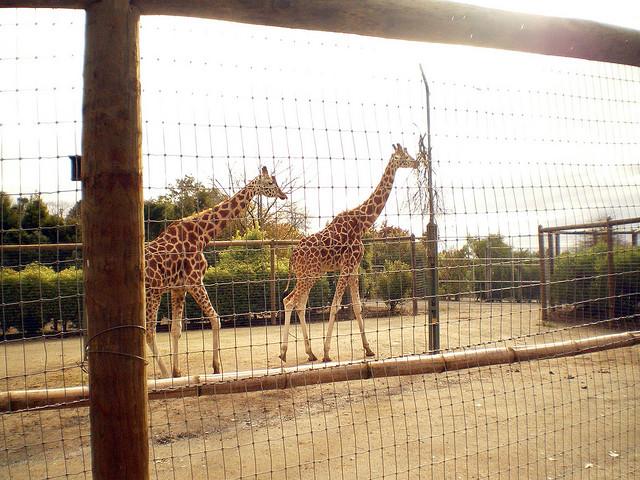Are the animals caged?
Answer briefly. Yes. How many animals are there?
Quick response, please. 2. What type of animal is in the photo?
Answer briefly. Giraffe. 